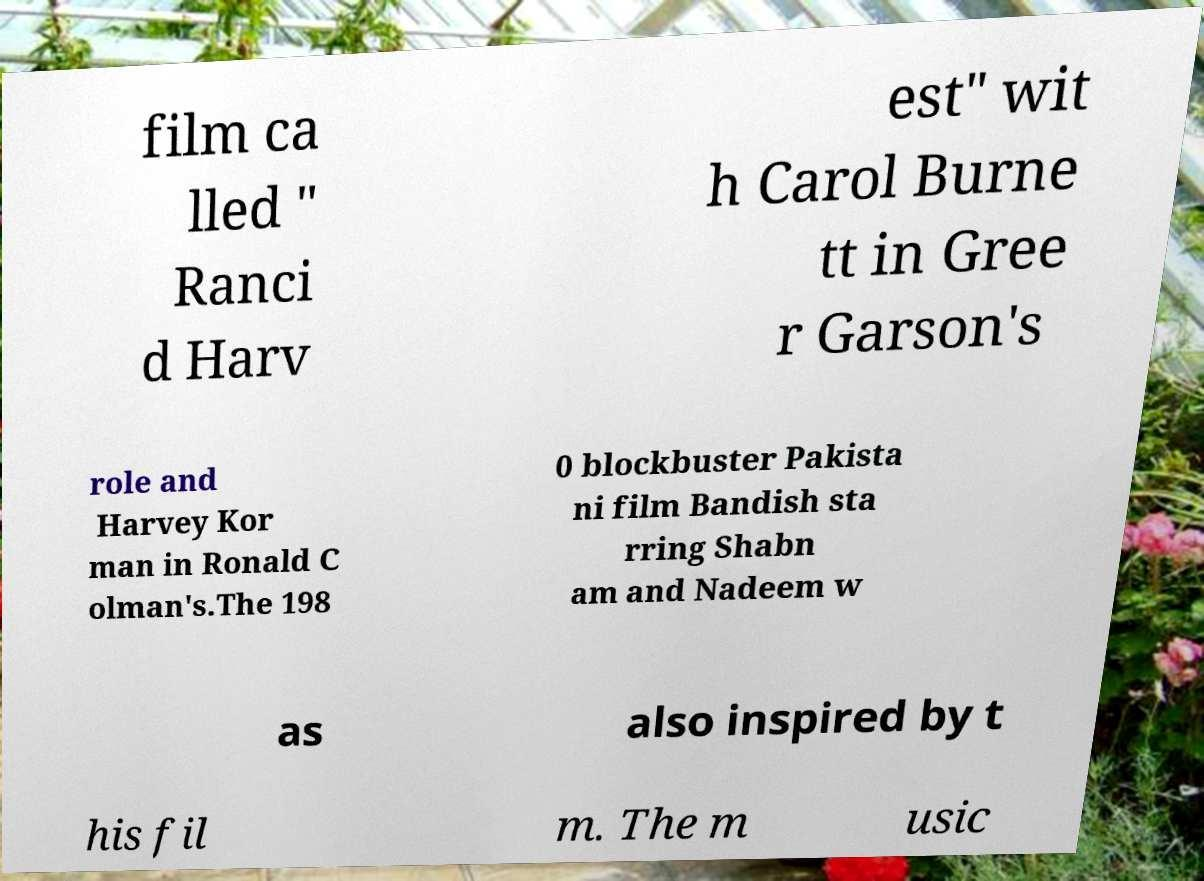Please identify and transcribe the text found in this image. film ca lled " Ranci d Harv est" wit h Carol Burne tt in Gree r Garson's role and Harvey Kor man in Ronald C olman's.The 198 0 blockbuster Pakista ni film Bandish sta rring Shabn am and Nadeem w as also inspired by t his fil m. The m usic 